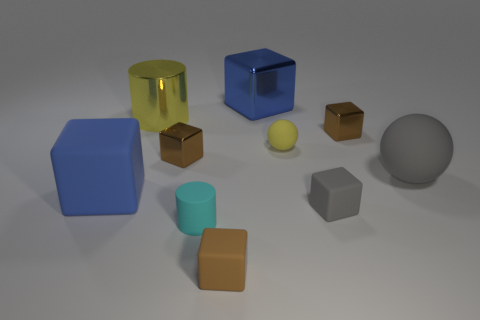There is a big cylinder that is the same color as the small sphere; what is it made of?
Your answer should be compact. Metal. What is the yellow sphere made of?
Ensure brevity in your answer.  Rubber. Do the big cube that is to the left of the small brown rubber object and the large gray sphere have the same material?
Ensure brevity in your answer.  Yes. What shape is the blue thing behind the gray ball?
Give a very brief answer. Cube. There is a gray cube that is the same size as the yellow rubber ball; what is its material?
Make the answer very short. Rubber. What number of objects are blue things that are in front of the tiny yellow matte object or cubes in front of the big yellow shiny cylinder?
Your answer should be compact. 5. What size is the blue cube that is the same material as the tiny yellow sphere?
Offer a terse response. Large. How many metallic things are either big objects or small cyan objects?
Provide a short and direct response. 2. The gray block has what size?
Offer a terse response. Small. Is the yellow shiny cylinder the same size as the matte cylinder?
Keep it short and to the point. No. 